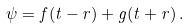<formula> <loc_0><loc_0><loc_500><loc_500>\psi = f ( t - r ) + g ( t + r ) \, .</formula> 